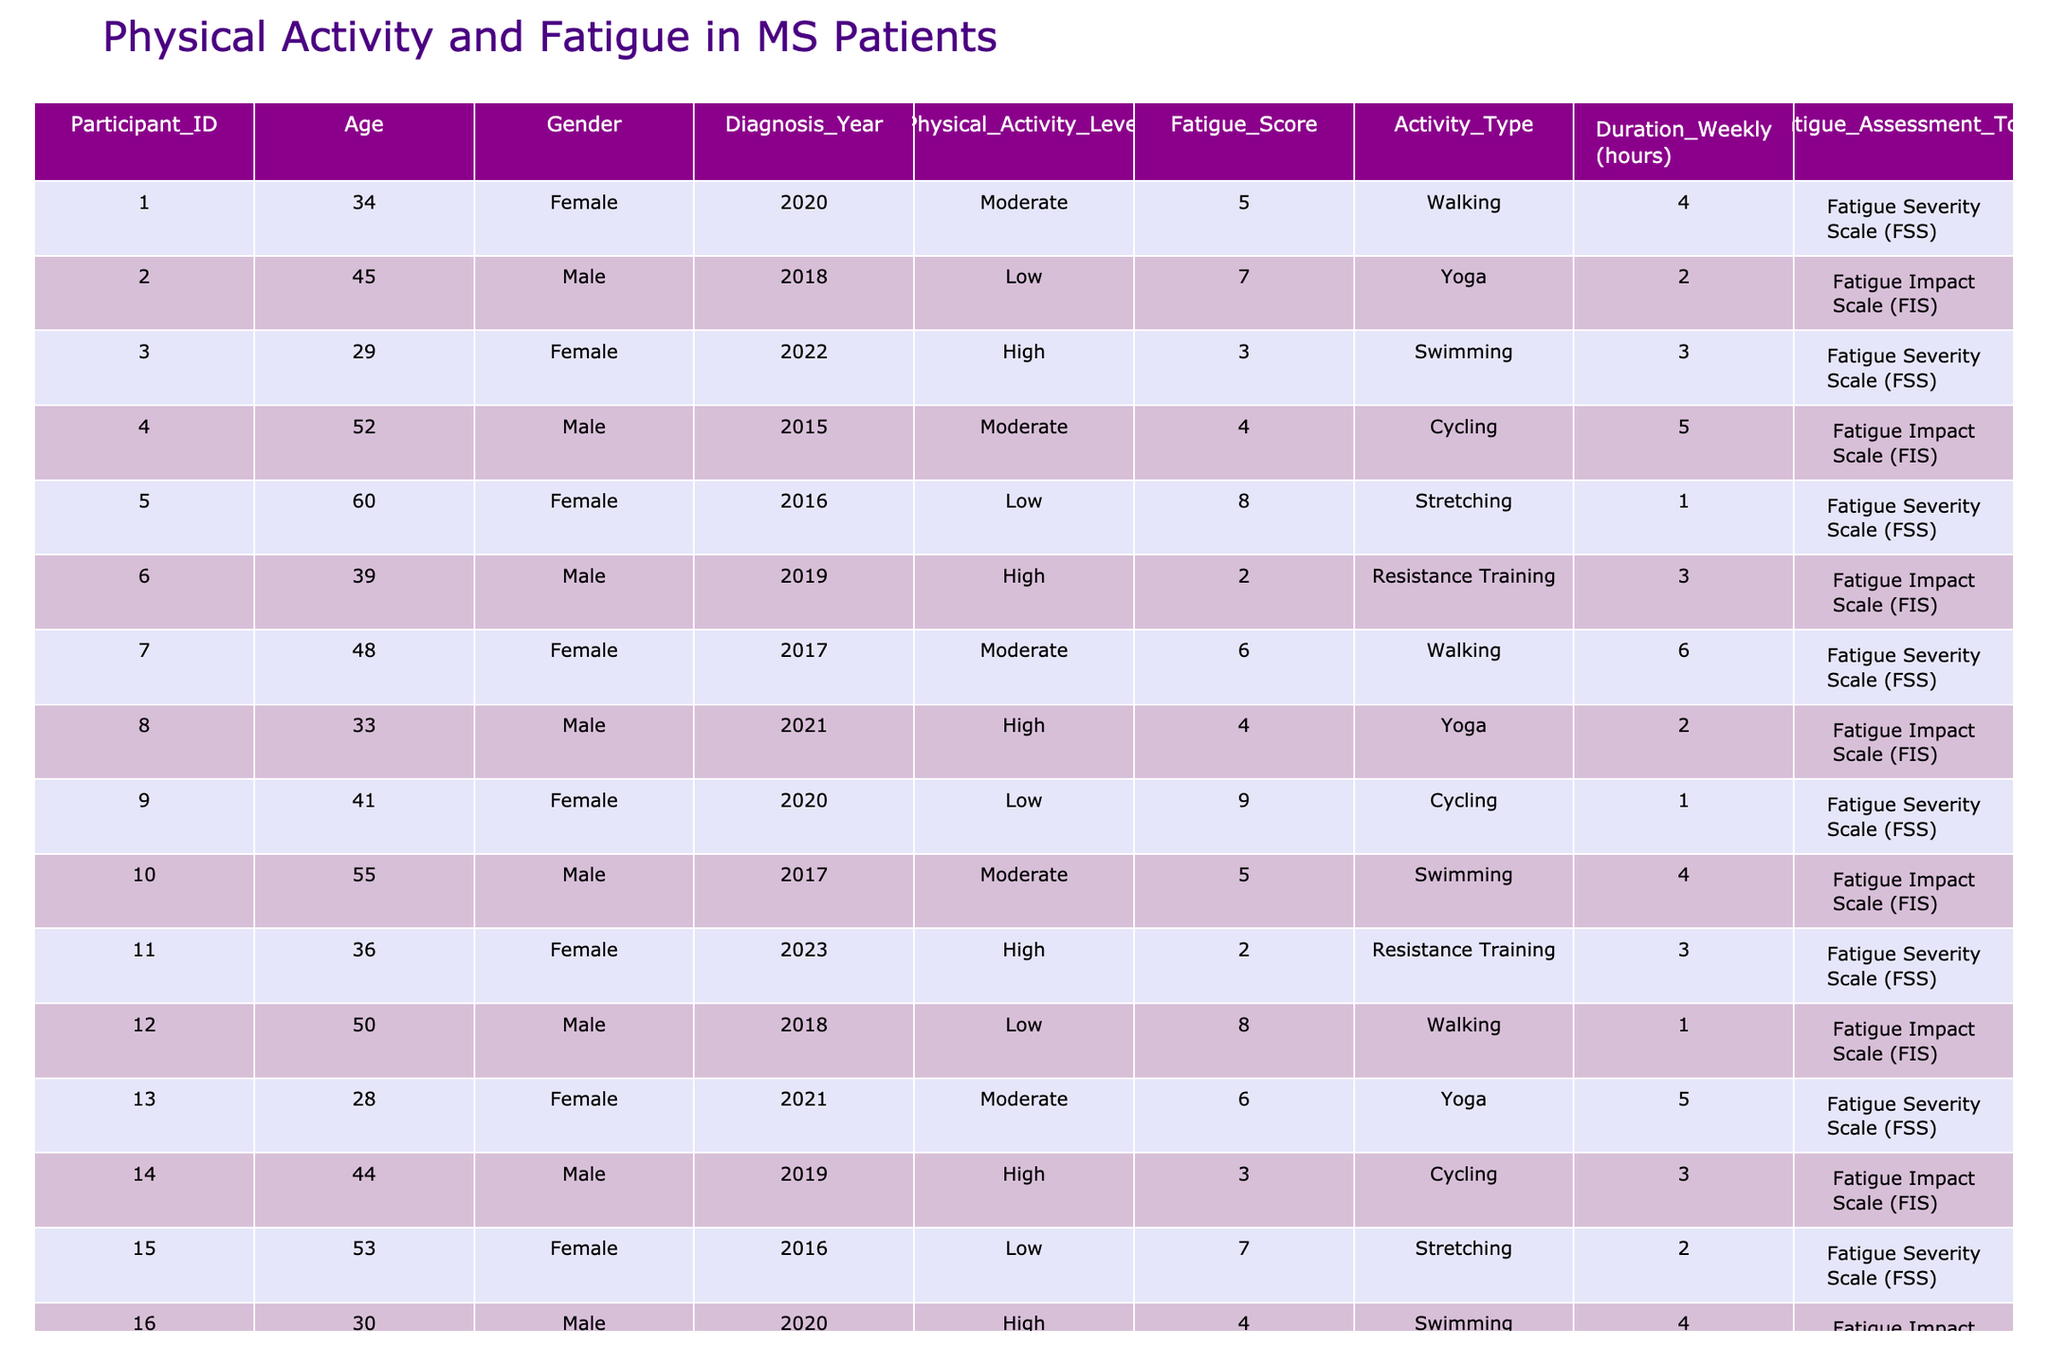What is the Physical Activity Level of Participant 1? According to the table, Participant 1 has a Physical Activity Level classified as "Moderate."
Answer: Moderate Which gender has the highest number of participants? By counting the number of occurrences for each gender in the table, there are 10 females and 10 males, so both genders have an equal number of participants.
Answer: Equal What is the most common Activity Type among participants with Low Physical Activity Levels? Reviewing the Activity Type column, participants with Low Physical Activity Levels engage in Yoga (2 participants) and Walking (2 participants), which are tied for the most common activity.
Answer: Yoga and Walking What is the average Fatigue Score for participants with a High Physical Activity Level? The Fatigue Scores for participants with High Physical Activity Level are 3, 4, 2, 3, 2, 4. Summing these values gives 18, and there are 6 participants, so the average is 18/6 = 3.
Answer: 3 Is there any participant who scored the highest Fatigue Score while having a Moderate Physical Activity Level? The highest Fatigue Score in the table is 9, obtained by a participant with Low Physical Activity Level (Participant 9), thus there is no participant meeting both criteria.
Answer: No Calculate the total hours spent on Physical Activity per week by female participants with a Low Physical Activity Level. Participants with Low Physical Activity Level are 5 (1 hour), 12 (1 hour), and 15 (2 hours). Summing these hours gives 1 + 1 + 2 = 4 hours.
Answer: 4 hours How many participants have a Fatigue Score of 2 or lower? By examining the Fatigue Score column, the values 2 are found for 5 participants: 6, 11, 8, 20. Therefore, there are four participants with a score of 2 or lower.
Answer: 4 What is the least common Activity Type among participants with a Low Physical Activity Level? For low activity, participants are mostly doing Yoga and Walking, whereas Stretching is performed by one participant. Thus, Stretching is the least common.
Answer: Stretching Which age group has the most participants with High Physical Activity Level? Looking through the Age column, participants with High Physical Activity Levels are ages 29, 33, 41, and 30, making 29 and 30 the only ages under 40.
Answer: Under 40 Identify if there is any participant who has been diagnosed with MS in the year 2023 and their Fatigue Score. There is one participant diagnosed in 2023 (Participant 11), who has a Fatigue Score of 2.
Answer: Yes, Score 2 